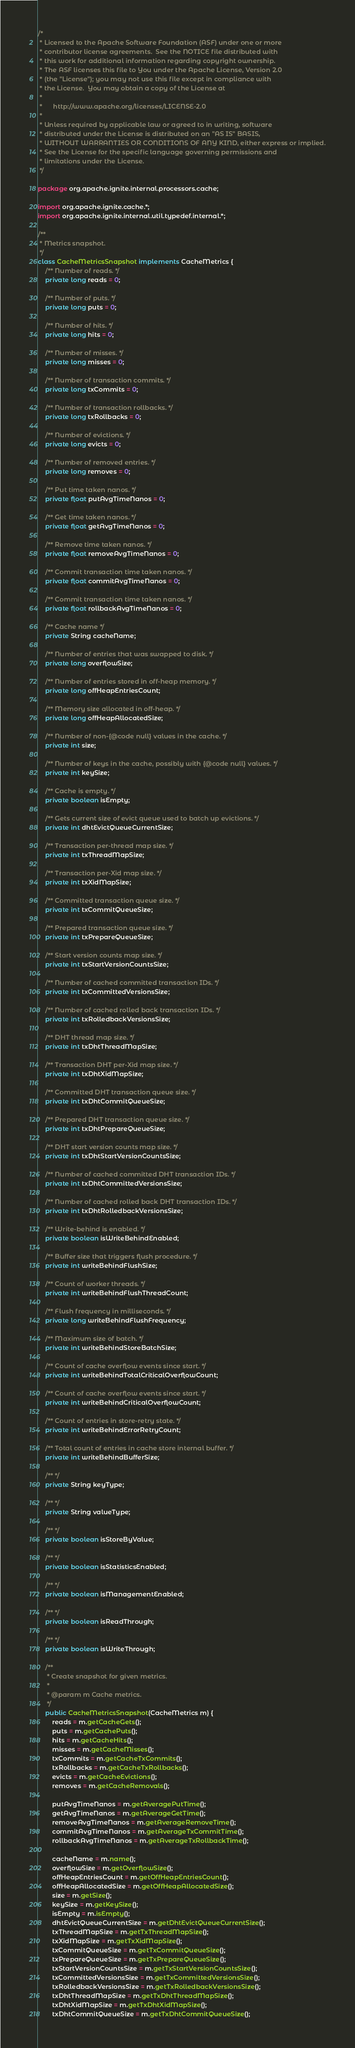Convert code to text. <code><loc_0><loc_0><loc_500><loc_500><_Java_>/*
 * Licensed to the Apache Software Foundation (ASF) under one or more
 * contributor license agreements.  See the NOTICE file distributed with
 * this work for additional information regarding copyright ownership.
 * The ASF licenses this file to You under the Apache License, Version 2.0
 * (the "License"); you may not use this file except in compliance with
 * the License.  You may obtain a copy of the License at
 *
 *      http://www.apache.org/licenses/LICENSE-2.0
 *
 * Unless required by applicable law or agreed to in writing, software
 * distributed under the License is distributed on an "AS IS" BASIS,
 * WITHOUT WARRANTIES OR CONDITIONS OF ANY KIND, either express or implied.
 * See the License for the specific language governing permissions and
 * limitations under the License.
 */

package org.apache.ignite.internal.processors.cache;

import org.apache.ignite.cache.*;
import org.apache.ignite.internal.util.typedef.internal.*;

/**
 * Metrics snapshot.
 */
class CacheMetricsSnapshot implements CacheMetrics {
    /** Number of reads. */
    private long reads = 0;

    /** Number of puts. */
    private long puts = 0;

    /** Number of hits. */
    private long hits = 0;

    /** Number of misses. */
    private long misses = 0;

    /** Number of transaction commits. */
    private long txCommits = 0;

    /** Number of transaction rollbacks. */
    private long txRollbacks = 0;

    /** Number of evictions. */
    private long evicts = 0;

    /** Number of removed entries. */
    private long removes = 0;

    /** Put time taken nanos. */
    private float putAvgTimeNanos = 0;

    /** Get time taken nanos. */
    private float getAvgTimeNanos = 0;

    /** Remove time taken nanos. */
    private float removeAvgTimeNanos = 0;

    /** Commit transaction time taken nanos. */
    private float commitAvgTimeNanos = 0;

    /** Commit transaction time taken nanos. */
    private float rollbackAvgTimeNanos = 0;

    /** Cache name */
    private String cacheName;

    /** Number of entries that was swapped to disk. */
    private long overflowSize;

    /** Number of entries stored in off-heap memory. */
    private long offHeapEntriesCount;

    /** Memory size allocated in off-heap. */
    private long offHeapAllocatedSize;

    /** Number of non-{@code null} values in the cache. */
    private int size;

    /** Number of keys in the cache, possibly with {@code null} values. */
    private int keySize;

    /** Cache is empty. */
    private boolean isEmpty;

    /** Gets current size of evict queue used to batch up evictions. */
    private int dhtEvictQueueCurrentSize;

    /** Transaction per-thread map size. */
    private int txThreadMapSize;

    /** Transaction per-Xid map size. */
    private int txXidMapSize;

    /** Committed transaction queue size. */
    private int txCommitQueueSize;

    /** Prepared transaction queue size. */
    private int txPrepareQueueSize;

    /** Start version counts map size. */
    private int txStartVersionCountsSize;

    /** Number of cached committed transaction IDs. */
    private int txCommittedVersionsSize;

    /** Number of cached rolled back transaction IDs. */
    private int txRolledbackVersionsSize;

    /** DHT thread map size. */
    private int txDhtThreadMapSize;

    /** Transaction DHT per-Xid map size. */
    private int txDhtXidMapSize;

    /** Committed DHT transaction queue size. */
    private int txDhtCommitQueueSize;

    /** Prepared DHT transaction queue size. */
    private int txDhtPrepareQueueSize;

    /** DHT start version counts map size. */
    private int txDhtStartVersionCountsSize;

    /** Number of cached committed DHT transaction IDs. */
    private int txDhtCommittedVersionsSize;

    /** Number of cached rolled back DHT transaction IDs. */
    private int txDhtRolledbackVersionsSize;

    /** Write-behind is enabled. */
    private boolean isWriteBehindEnabled;

    /** Buffer size that triggers flush procedure. */
    private int writeBehindFlushSize;

    /** Count of worker threads. */
    private int writeBehindFlushThreadCount;

    /** Flush frequency in milliseconds. */
    private long writeBehindFlushFrequency;

    /** Maximum size of batch. */
    private int writeBehindStoreBatchSize;

    /** Count of cache overflow events since start. */
    private int writeBehindTotalCriticalOverflowCount;

    /** Count of cache overflow events since start. */
    private int writeBehindCriticalOverflowCount;

    /** Count of entries in store-retry state. */
    private int writeBehindErrorRetryCount;

    /** Total count of entries in cache store internal buffer. */
    private int writeBehindBufferSize;

    /** */
    private String keyType;

    /** */
    private String valueType;

    /** */
    private boolean isStoreByValue;

    /** */
    private boolean isStatisticsEnabled;

    /** */
    private boolean isManagementEnabled;

    /** */
    private boolean isReadThrough;

    /** */
    private boolean isWriteThrough;

    /**
     * Create snapshot for given metrics.
     *
     * @param m Cache metrics.
     */
    public CacheMetricsSnapshot(CacheMetrics m) {
        reads = m.getCacheGets();
        puts = m.getCachePuts();
        hits = m.getCacheHits();
        misses = m.getCacheMisses();
        txCommits = m.getCacheTxCommits();
        txRollbacks = m.getCacheTxRollbacks();
        evicts = m.getCacheEvictions();
        removes = m.getCacheRemovals();

        putAvgTimeNanos = m.getAveragePutTime();
        getAvgTimeNanos = m.getAverageGetTime();
        removeAvgTimeNanos = m.getAverageRemoveTime();
        commitAvgTimeNanos = m.getAverageTxCommitTime();
        rollbackAvgTimeNanos = m.getAverageTxRollbackTime();

        cacheName = m.name();
        overflowSize = m.getOverflowSize();
        offHeapEntriesCount = m.getOffHeapEntriesCount();
        offHeapAllocatedSize = m.getOffHeapAllocatedSize();
        size = m.getSize();
        keySize = m.getKeySize();
        isEmpty = m.isEmpty();
        dhtEvictQueueCurrentSize = m.getDhtEvictQueueCurrentSize();
        txThreadMapSize = m.getTxThreadMapSize();
        txXidMapSize = m.getTxXidMapSize();
        txCommitQueueSize = m.getTxCommitQueueSize();
        txPrepareQueueSize = m.getTxPrepareQueueSize();
        txStartVersionCountsSize = m.getTxStartVersionCountsSize();
        txCommittedVersionsSize = m.getTxCommittedVersionsSize();
        txRolledbackVersionsSize = m.getTxRolledbackVersionsSize();
        txDhtThreadMapSize = m.getTxDhtThreadMapSize();
        txDhtXidMapSize = m.getTxDhtXidMapSize();
        txDhtCommitQueueSize = m.getTxDhtCommitQueueSize();</code> 